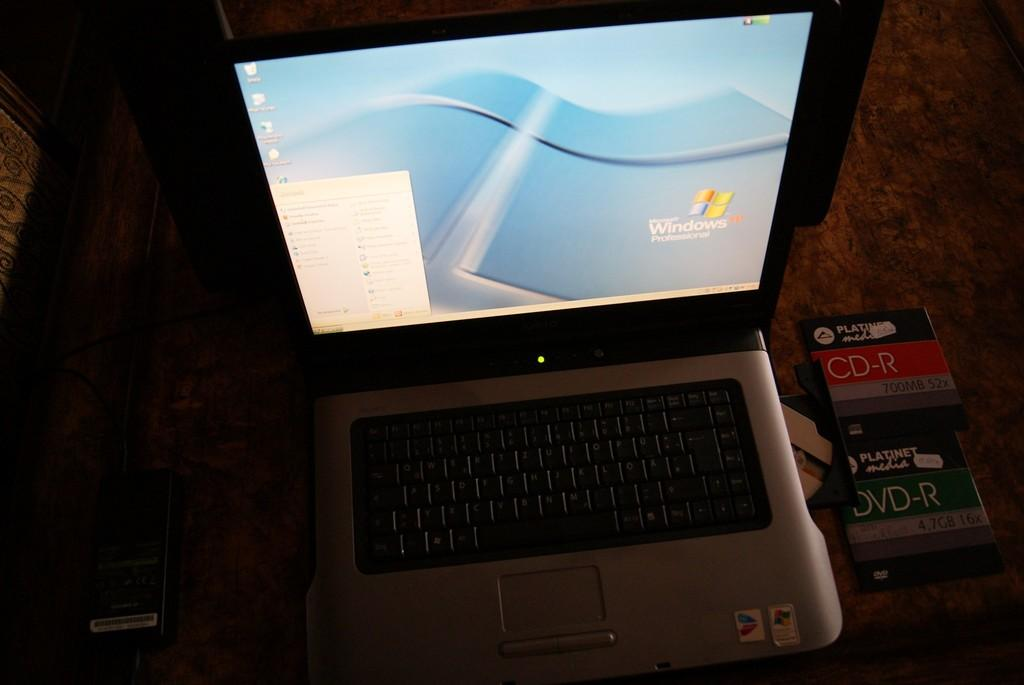What electronic device is visible in the image? There is a laptop in the image. What type of media is present in the image? There is a DVD in the image. Where are the laptop and DVD located? Both the laptop and DVD are placed on a table. What can be inferred about the lighting conditions in the image? The background of the image is dark. Can you describe the slope of the house in the image? There is no house present in the image, only a laptop and a DVD on a table. How many people are walking in the image? There are no people visible in the image, so it is impossible to determine the number of people walking. 